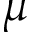Convert formula to latex. <formula><loc_0><loc_0><loc_500><loc_500>\mu</formula> 